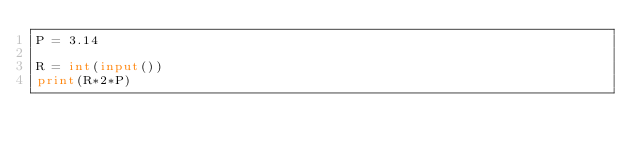<code> <loc_0><loc_0><loc_500><loc_500><_Python_>P = 3.14

R = int(input())
print(R*2*P)</code> 